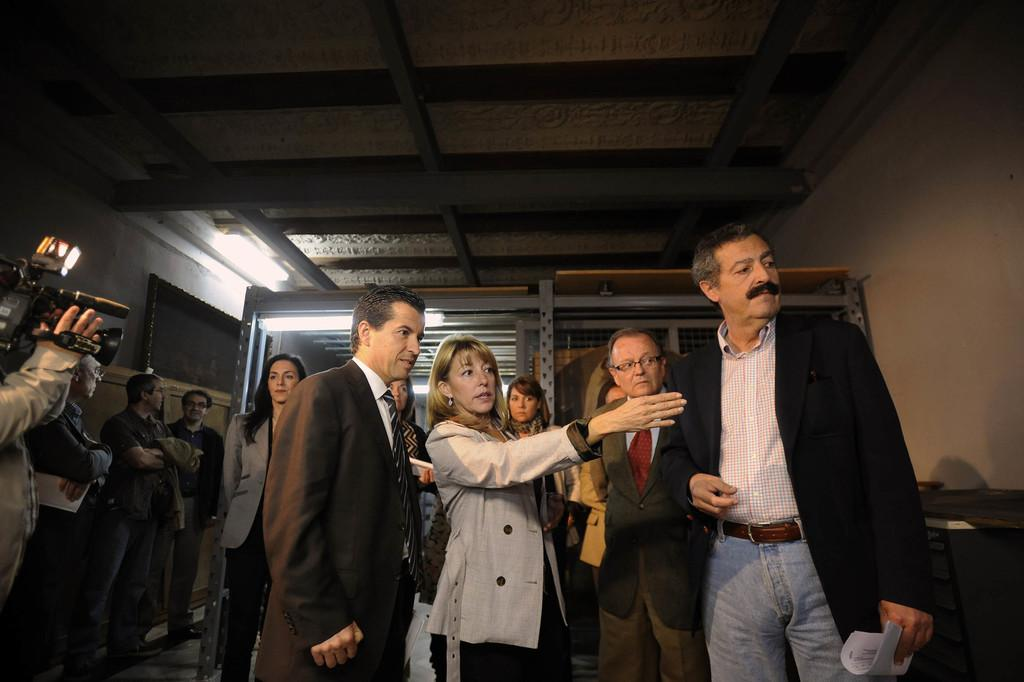What types of people are in the image? There are men and women in the image. Where are the people located in the image? The people are standing on the floor. What is one person doing with their hands? One person is holding a camera in their hands. What can be seen in the background of the image? There are walls, electric lights, and grills visible in the background of the image. What title does the person holding the camera have in the image? There is no indication of a title for the person holding the camera in the image. How does the person holding the camera express regret in the image? There is no indication of regret or any emotional expression in the image. 